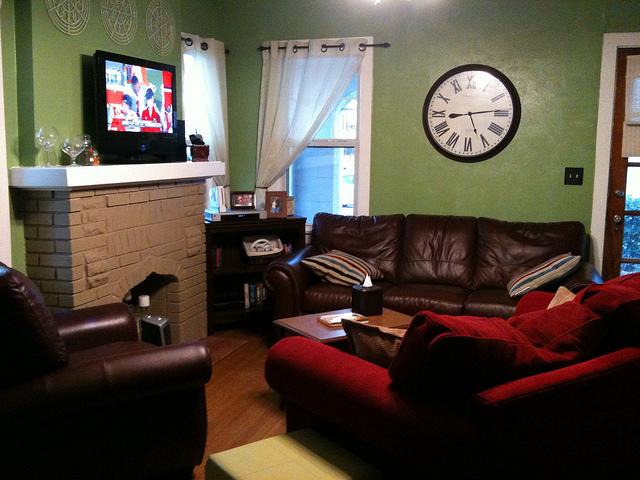What time is it in the photo?
Short answer required. 5:15. What's the fireplace made of?
Be succinct. Brick. What sort of box is on the coffee table?
Answer briefly. Tissue. 